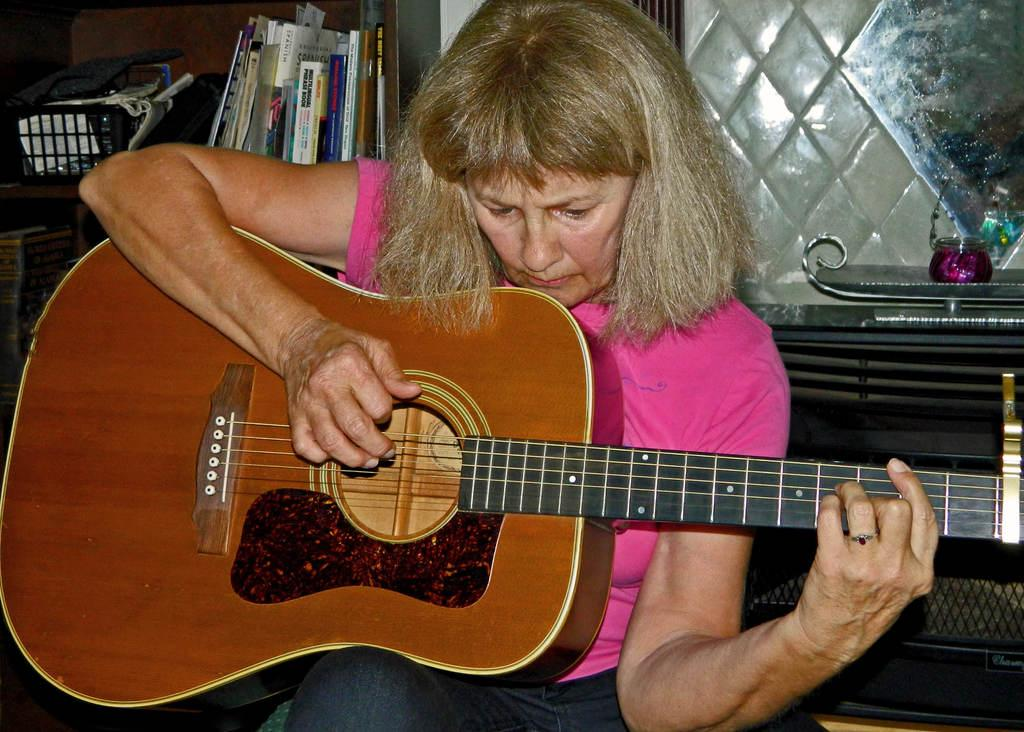Who is the main subject in the image? There is a woman in the image. What is the woman doing in the image? The woman is sitting and playing the guitar. What can be seen in the background of the image? There are books, a box, a plate, a jar, and a wall in the background of the image. What type of van can be seen distributing change in the image? There is no van or distribution of change present in the image. 